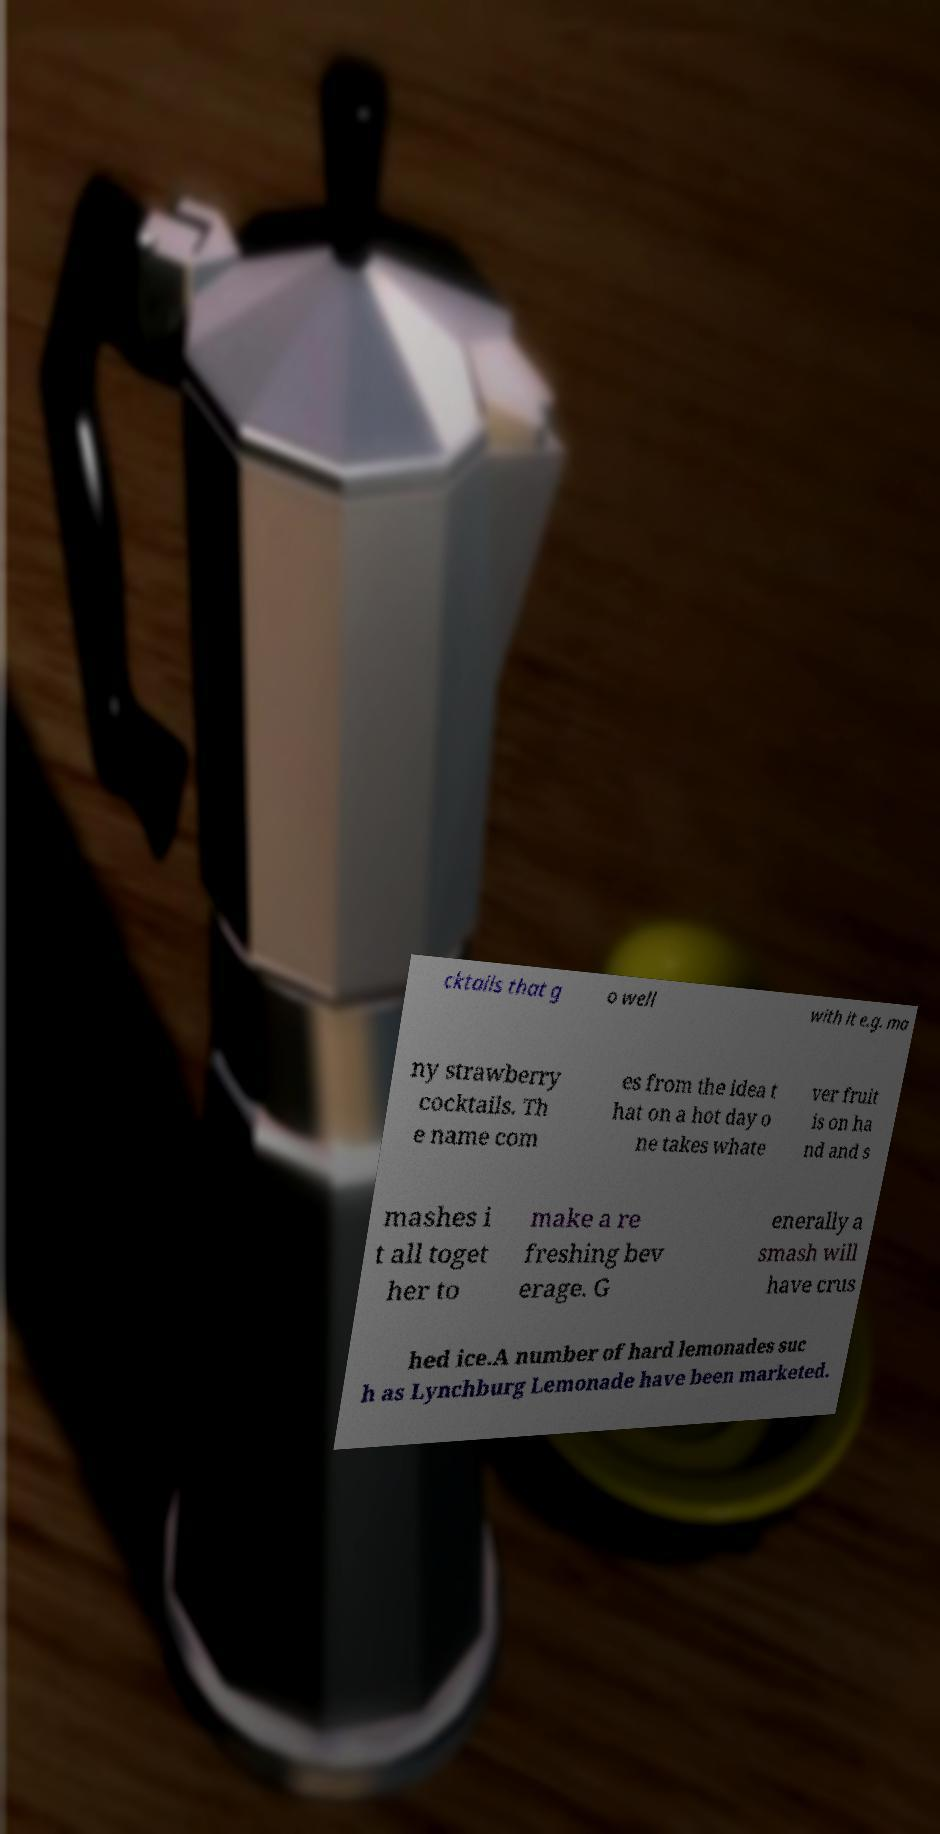Could you assist in decoding the text presented in this image and type it out clearly? cktails that g o well with it e.g. ma ny strawberry cocktails. Th e name com es from the idea t hat on a hot day o ne takes whate ver fruit is on ha nd and s mashes i t all toget her to make a re freshing bev erage. G enerally a smash will have crus hed ice.A number of hard lemonades suc h as Lynchburg Lemonade have been marketed. 